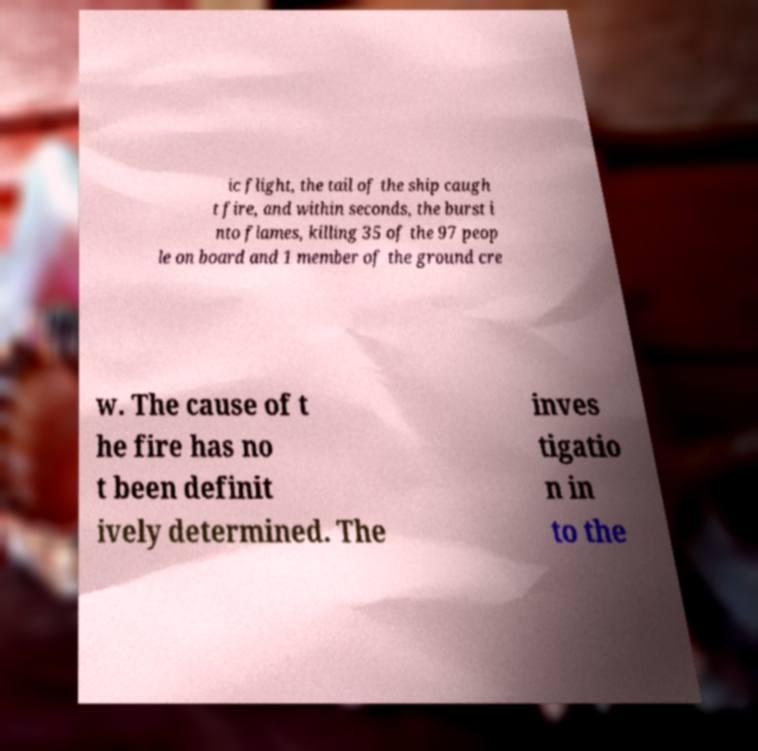What messages or text are displayed in this image? I need them in a readable, typed format. ic flight, the tail of the ship caugh t fire, and within seconds, the burst i nto flames, killing 35 of the 97 peop le on board and 1 member of the ground cre w. The cause of t he fire has no t been definit ively determined. The inves tigatio n in to the 